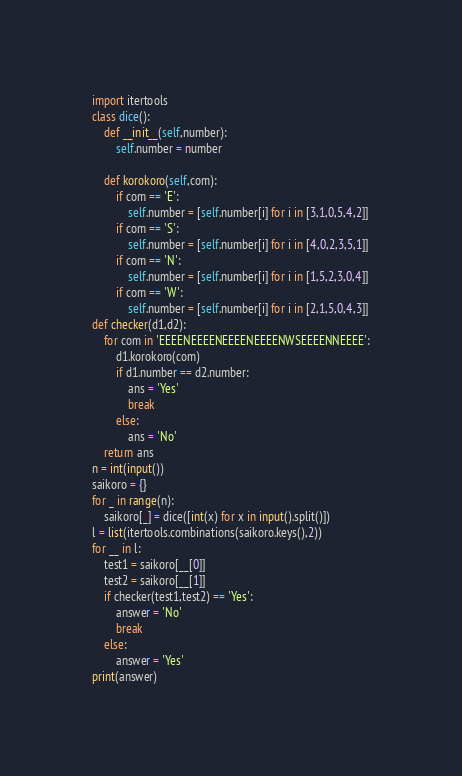Convert code to text. <code><loc_0><loc_0><loc_500><loc_500><_Python_>import itertools
class dice():
    def __init__(self,number):
        self.number = number
 
    def korokoro(self,com):
        if com == 'E':
            self.number = [self.number[i] for i in [3,1,0,5,4,2]]
        if com == 'S':
            self.number = [self.number[i] for i in [4,0,2,3,5,1]]
        if com == 'N':
            self.number = [self.number[i] for i in [1,5,2,3,0,4]]
        if com == 'W':
            self.number = [self.number[i] for i in [2,1,5,0,4,3]]
def checker(d1,d2):
    for com in 'EEEENEEEENEEEENEEEENWSEEEENNEEEE':
        d1.korokoro(com)
        if d1.number == d2.number:
            ans = 'Yes'
            break
        else:
            ans = 'No'
    return ans
n = int(input())
saikoro = {}
for _ in range(n):
    saikoro[_] = dice([int(x) for x in input().split()])
l = list(itertools.combinations(saikoro.keys(),2))
for __ in l:
    test1 = saikoro[__[0]]
    test2 = saikoro[__[1]]
    if checker(test1,test2) == 'Yes':
        answer = 'No'
        break
    else:
        answer = 'Yes'
print(answer)

</code> 